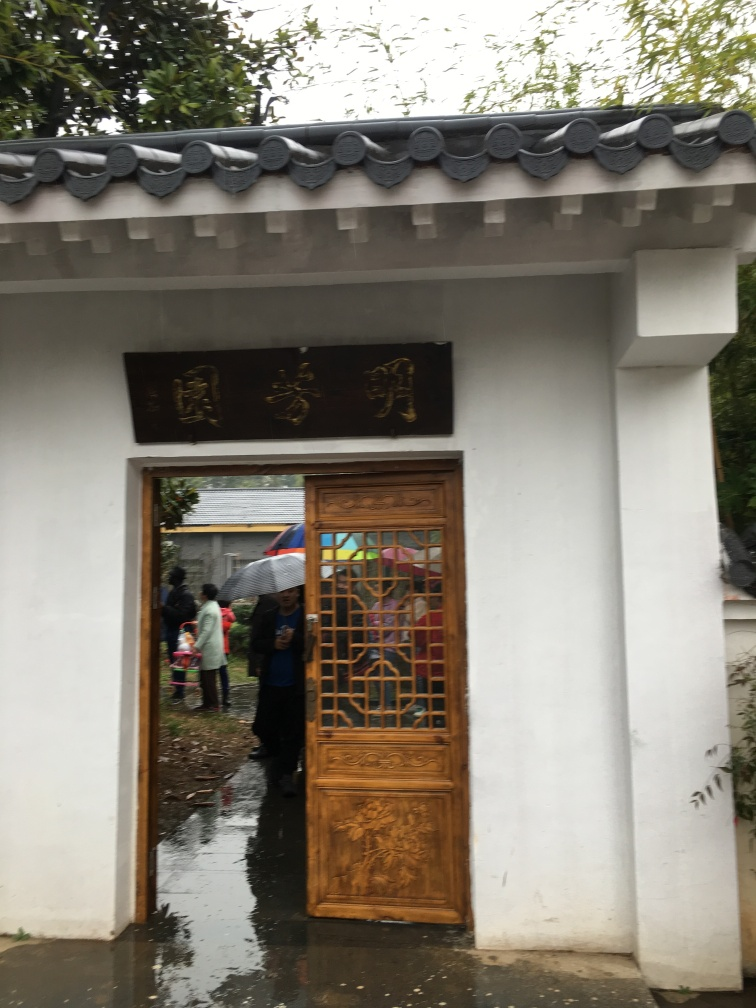Is the image blurry? The image is somewhat blurry, especially noticeable in the detailing of the door and the distant background where people are gathered. Despite this, the main elements, such as the doorway and the close-up parts of the door, are still recognizable. 